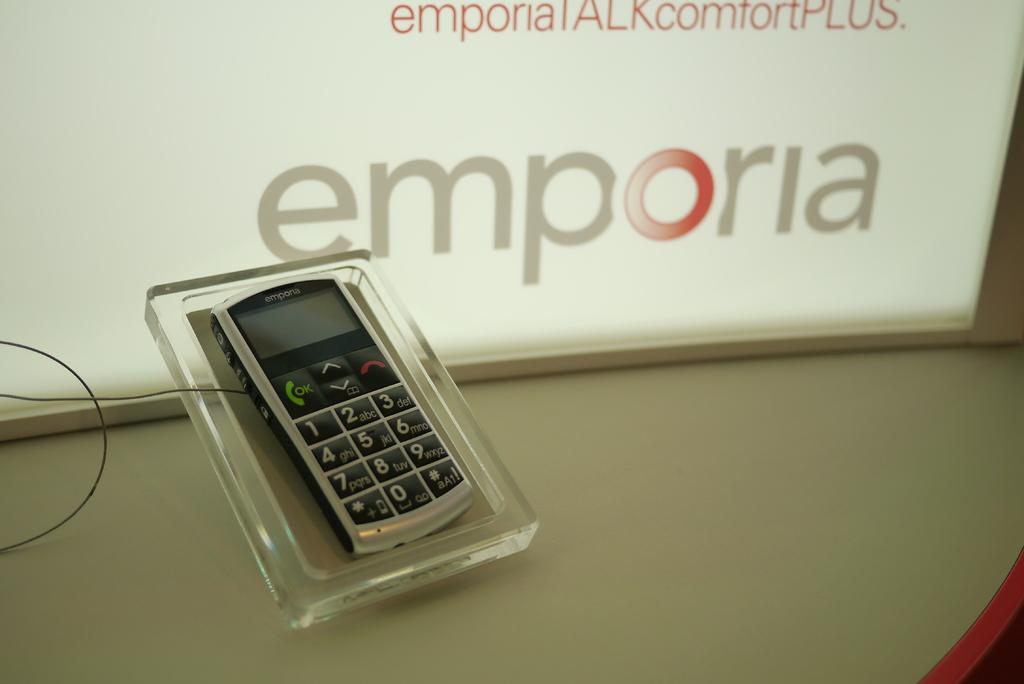<image>
Write a terse but informative summary of the picture. An emporia brand phone is on display with large number buttons: 1, 2, 3, 4, 5, 6, 7, 8, 9, and 0. 